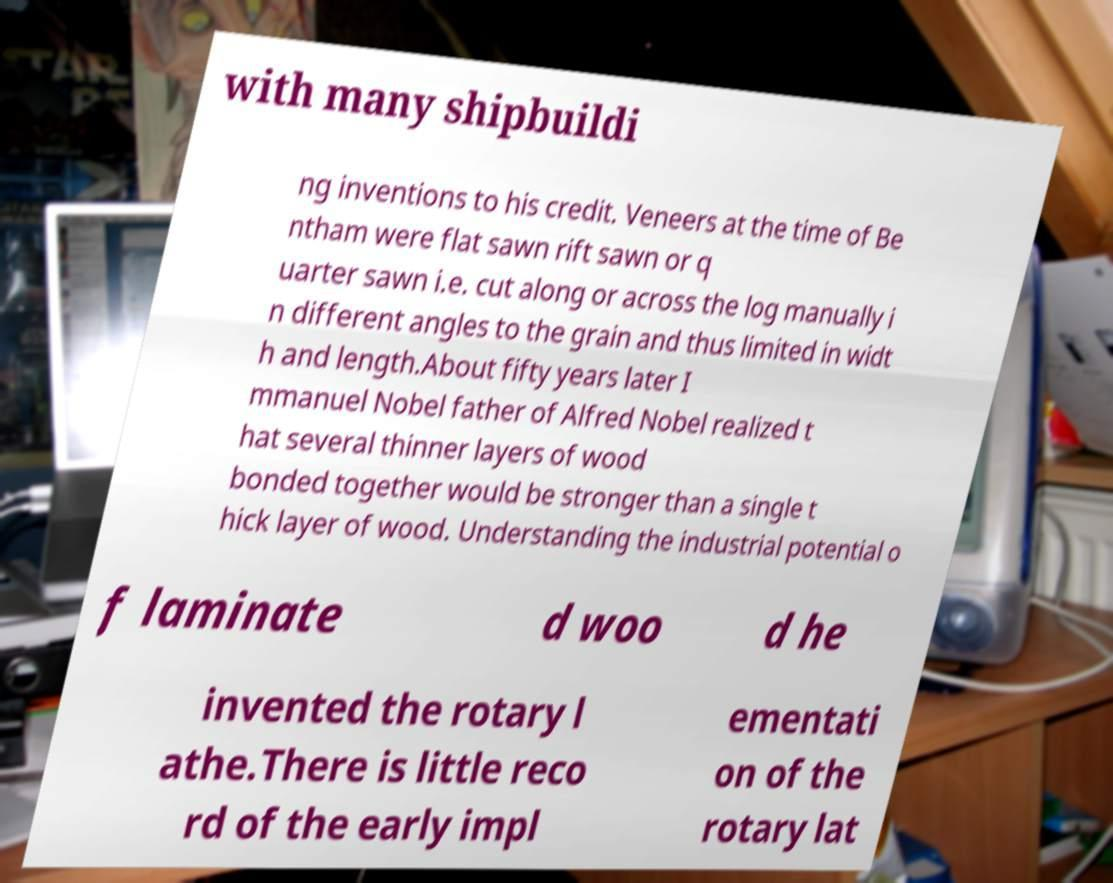There's text embedded in this image that I need extracted. Can you transcribe it verbatim? with many shipbuildi ng inventions to his credit. Veneers at the time of Be ntham were flat sawn rift sawn or q uarter sawn i.e. cut along or across the log manually i n different angles to the grain and thus limited in widt h and length.About fifty years later I mmanuel Nobel father of Alfred Nobel realized t hat several thinner layers of wood bonded together would be stronger than a single t hick layer of wood. Understanding the industrial potential o f laminate d woo d he invented the rotary l athe.There is little reco rd of the early impl ementati on of the rotary lat 